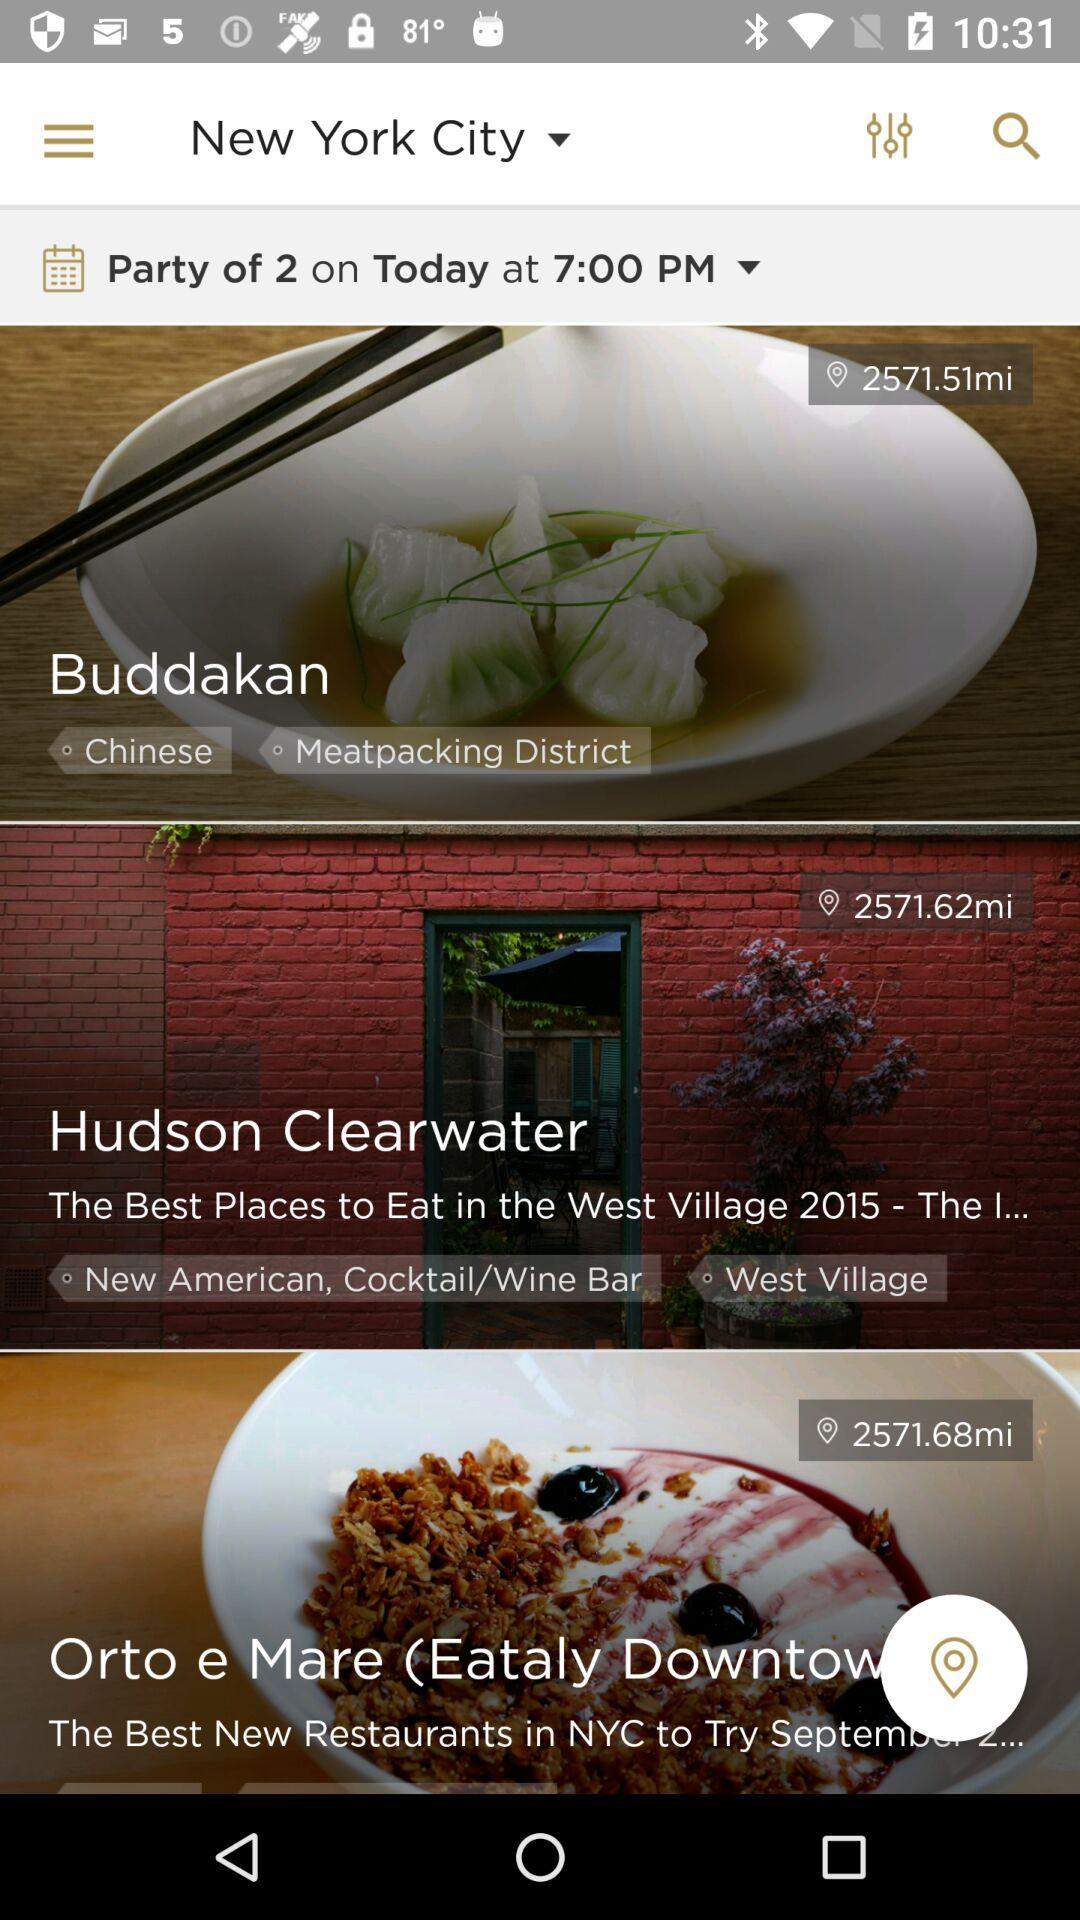What is the time of the party? The time of the party is 7:00 p.m. 